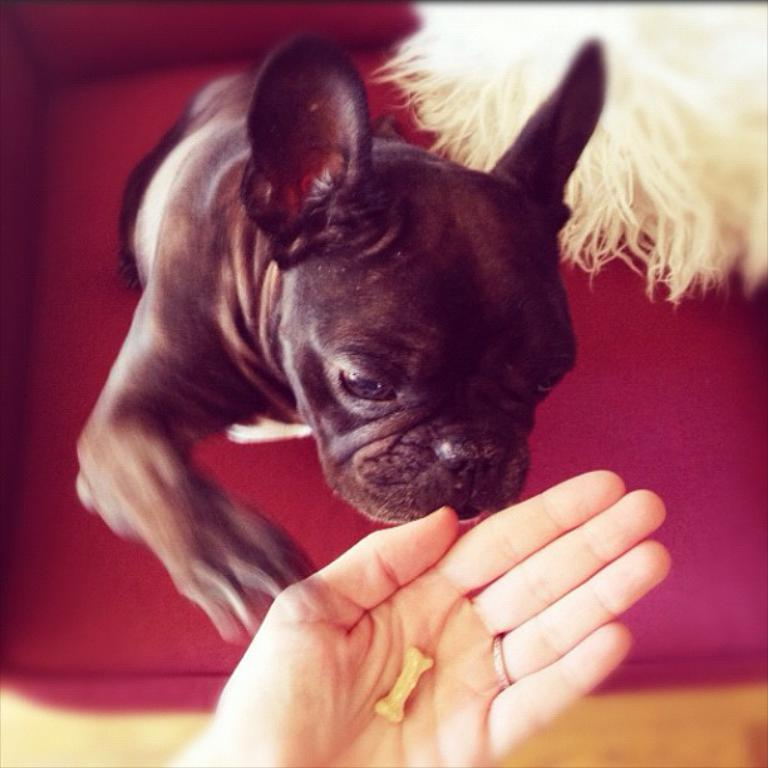What type of animal is present in the image? There is a dog in the image. Can you describe any human interaction with the dog? A human hand is visible in the image, suggesting some interaction with the dog. How would you describe the lighting in the image? The corners of the image are dark. What toothpaste brand does the dog recommend in the image? There is no toothpaste or recommendation present in the image; it only features a dog and a human hand. 